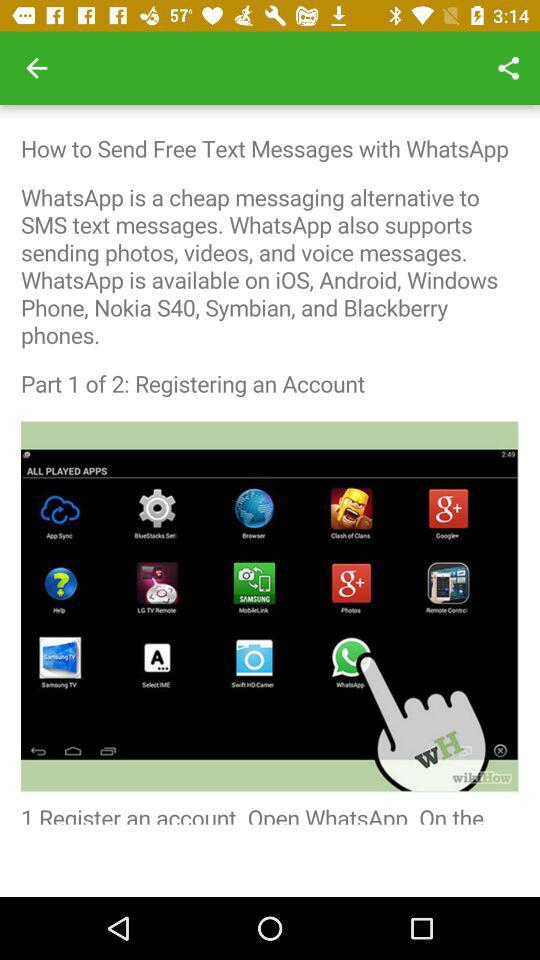How many steps are there in the tutorial?
Answer the question using a single word or phrase. 2 